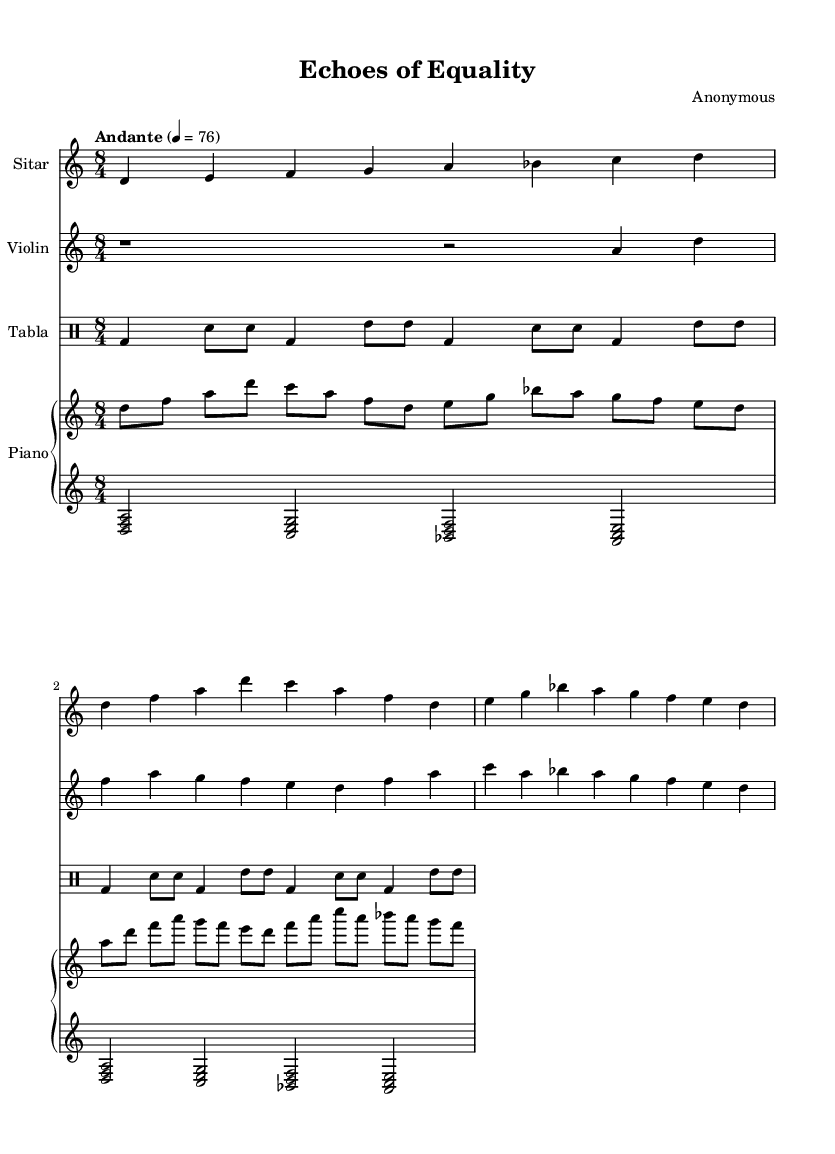What is the key signature of this music? The key signature indicates two sharps, which corresponds to the D major or B minor keys. Given that the piece is marked as D Dorian, it implies that the key signature is relevant to D major.
Answer: D major What is the time signature of this piece? The time signature is indicated at the beginning of the score. It shows '8/4', which means there are eight beats in a measure and a quarter note gets one beat.
Answer: 8/4 What is the tempo marking for this music? The tempo marking is found next to the tempo indication. "Andante" translates to a moderate speed, and the number 76 refers to the beats per minute.
Answer: Andante 76 What instruments are included in the composition? The instruments are explicitly mentioned at the start of each staff in the score. The instruments listed are Sitar, Violin, Tabla, and Piano.
Answer: Sitar, Violin, Tabla, Piano How many bars does the Sitar part have? The Sitar part consists of four measures as indicated by the grouping of notes and the end of each line, showing complete phrases.
Answer: 4 Which instrument is primarily responsible for rhythm in this composition? The Tabla is designated as the drum and is visually presented in a separate drum staff, indicating its role in maintaining the rhythmic foundation of the piece.
Answer: Tabla What musical style does this piece exemplify? The combination of Indian classical elements with Western instruments, along with themes related to social justice, signifies a fusion style typical of World Music.
Answer: Fusion of Indian classical and Western instruments 